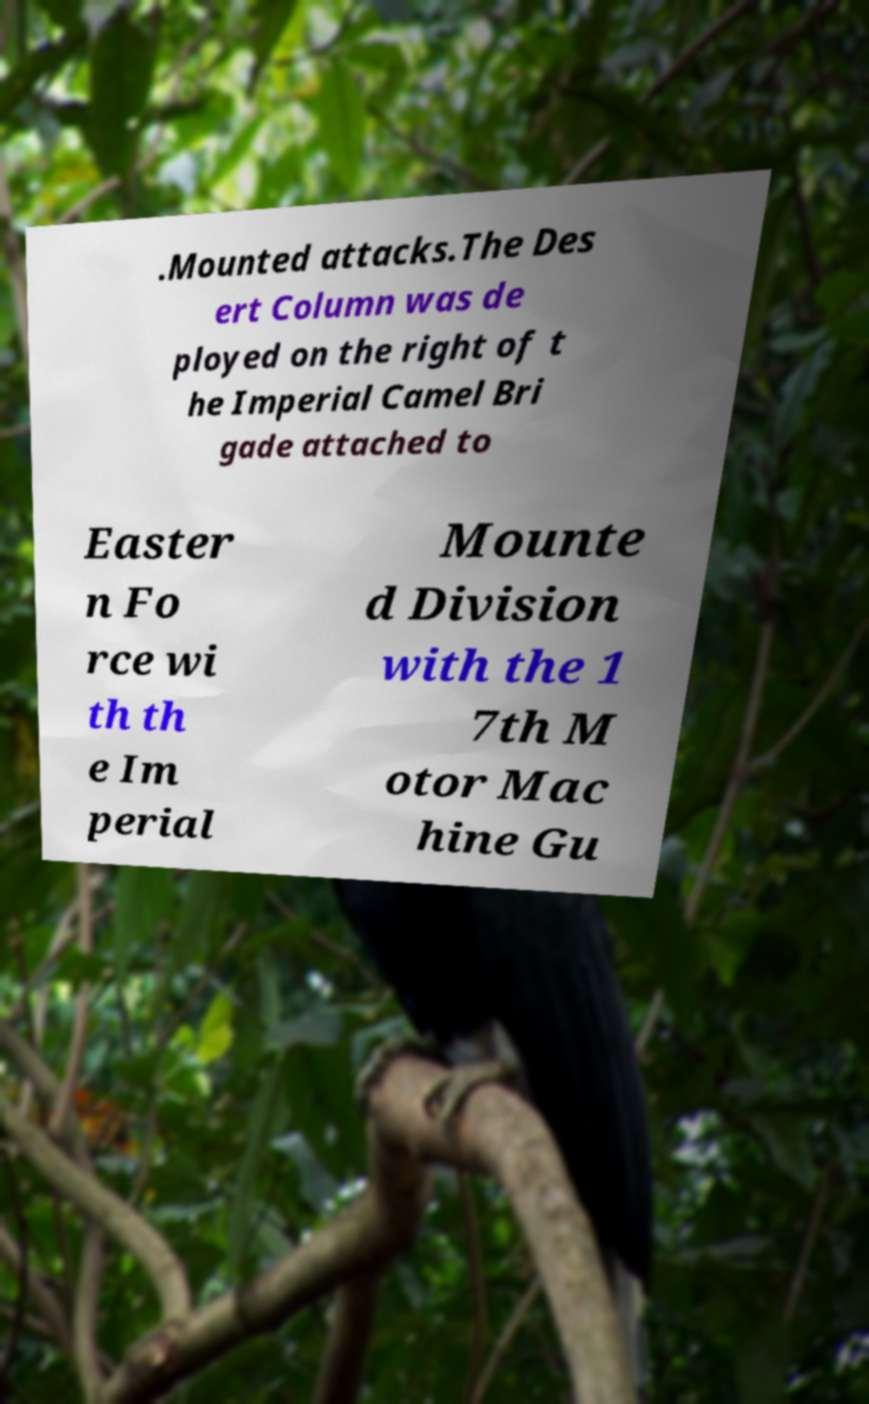Please identify and transcribe the text found in this image. .Mounted attacks.The Des ert Column was de ployed on the right of t he Imperial Camel Bri gade attached to Easter n Fo rce wi th th e Im perial Mounte d Division with the 1 7th M otor Mac hine Gu 